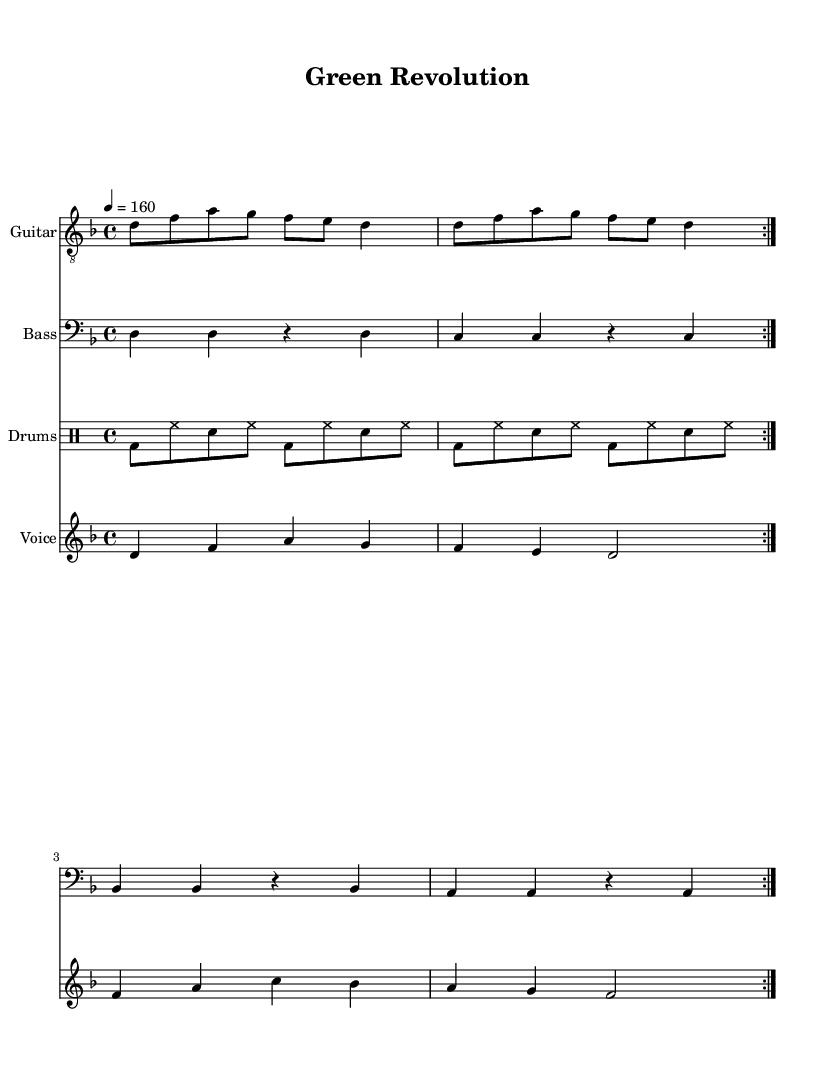What is the key signature of this music? The key signature is indicated at the beginning of the sheet music. Here it shows one flat, which signifies that it is in D minor.
Answer: D minor What is the time signature of this music? The time signature is noted at the beginning of the sheet music, which displays a "4" over a "4". This indicates four beats per measure, categorizing the piece as a common time.
Answer: 4/4 What is the tempo marking for this piece? The tempo marking is present as "4 = 160," suggesting that there are 160 beats per minute when coordinating with a quarter note.
Answer: 160 How many times is the guitar riff repeated? Looking at the guitar part, it specifies that the riff is to be repeated two times, as indicated by "repeat volta 2."
Answer: 2 What is the main theme expressed in the lyrics of the chorus? The lyrics of the chorus clearly speak about a call to action regarding the environment, with phrases emphasizing the need to "rise" and "save our future." Thus, it focuses on rallying for environmental change.
Answer: Save our future Which instruments are included in this arrangement? The sheet music explicitly lists the instruments in the score sections: Guitar, Bass, Drums, and Voice. This information is found in the individual staff instrument names.
Answer: Guitar, Bass, Drums, Voice What lyrical message does the verse convey regarding the environment? The verse highlights issues like "polluted skies" and "dying trees," indicating themes related to the degradation of the environment and the consequences of pollution. It succinctly addresses the adverse effects of human activity on nature.
Answer: Pollution and destruction 